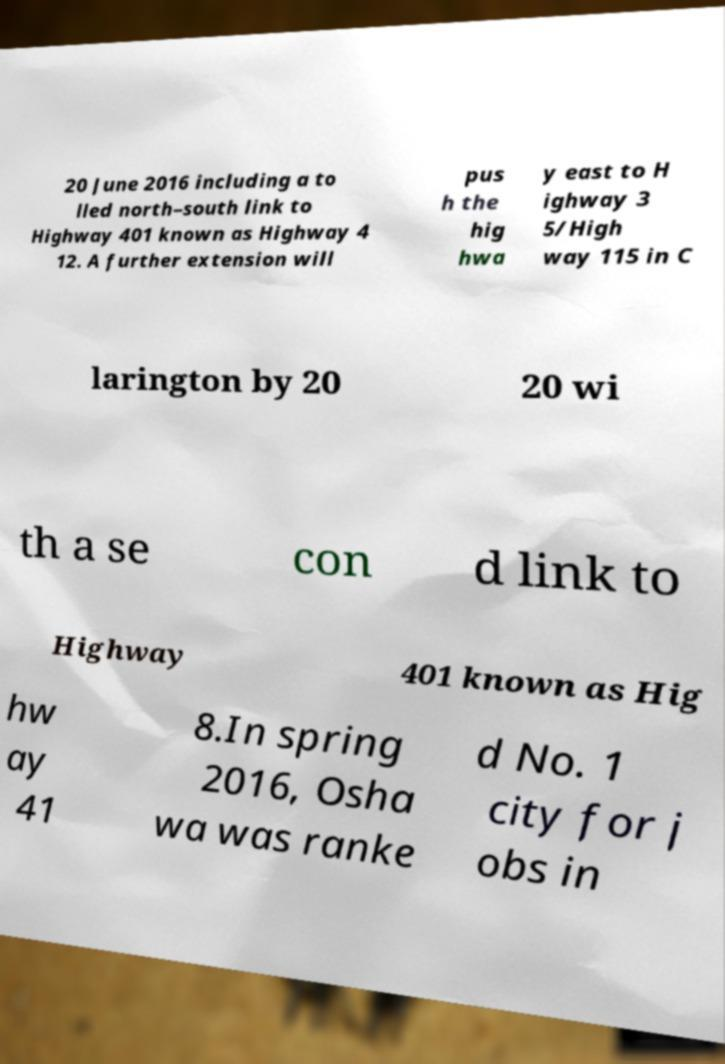Please identify and transcribe the text found in this image. 20 June 2016 including a to lled north–south link to Highway 401 known as Highway 4 12. A further extension will pus h the hig hwa y east to H ighway 3 5/High way 115 in C larington by 20 20 wi th a se con d link to Highway 401 known as Hig hw ay 41 8.In spring 2016, Osha wa was ranke d No. 1 city for j obs in 